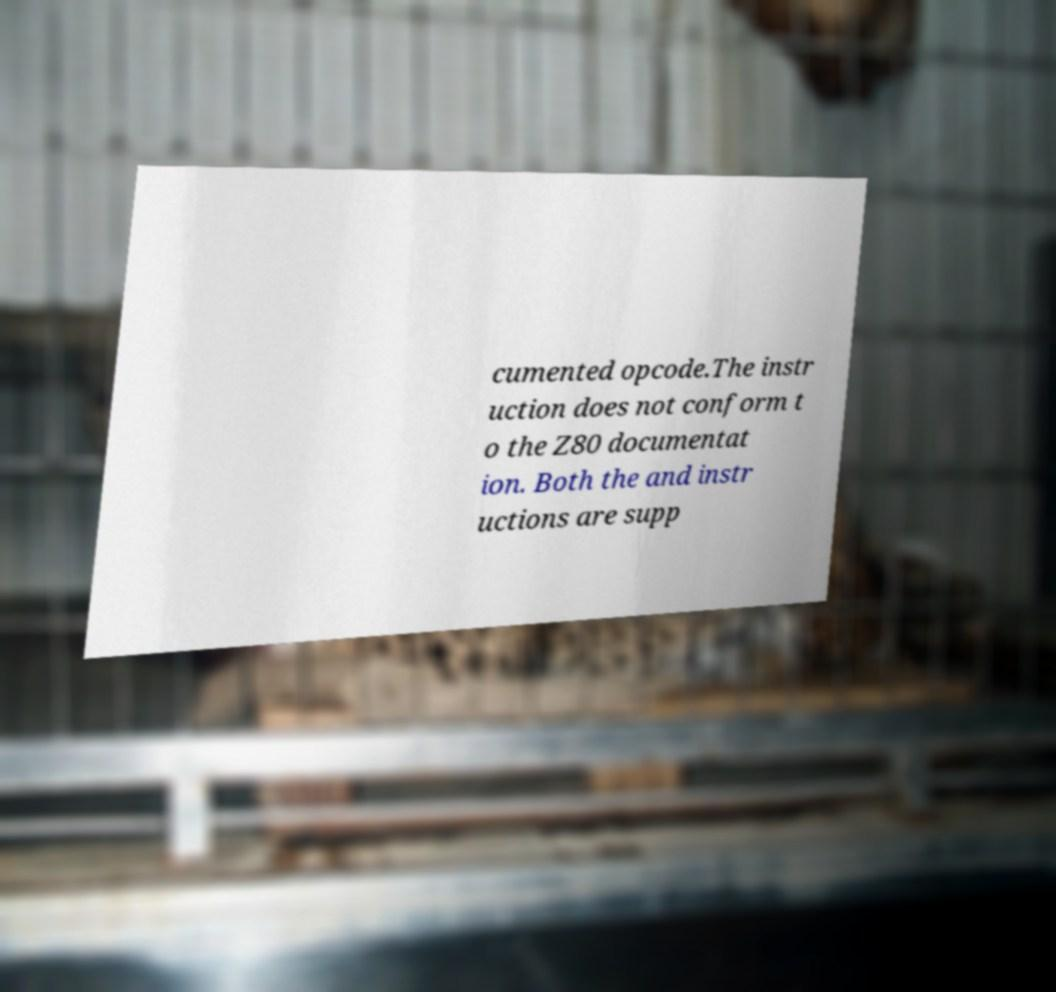For documentation purposes, I need the text within this image transcribed. Could you provide that? cumented opcode.The instr uction does not conform t o the Z80 documentat ion. Both the and instr uctions are supp 